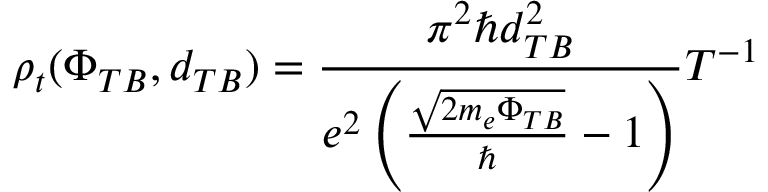<formula> <loc_0><loc_0><loc_500><loc_500>\rho _ { t } ( \Phi _ { T B } , d _ { T B } ) = \frac { \pi ^ { 2 } \hbar { d } _ { T B } ^ { 2 } } { e ^ { 2 } \left ( \frac { \sqrt { 2 m _ { e } \Phi _ { T B } } } { } - 1 \right ) } T ^ { - 1 }</formula> 